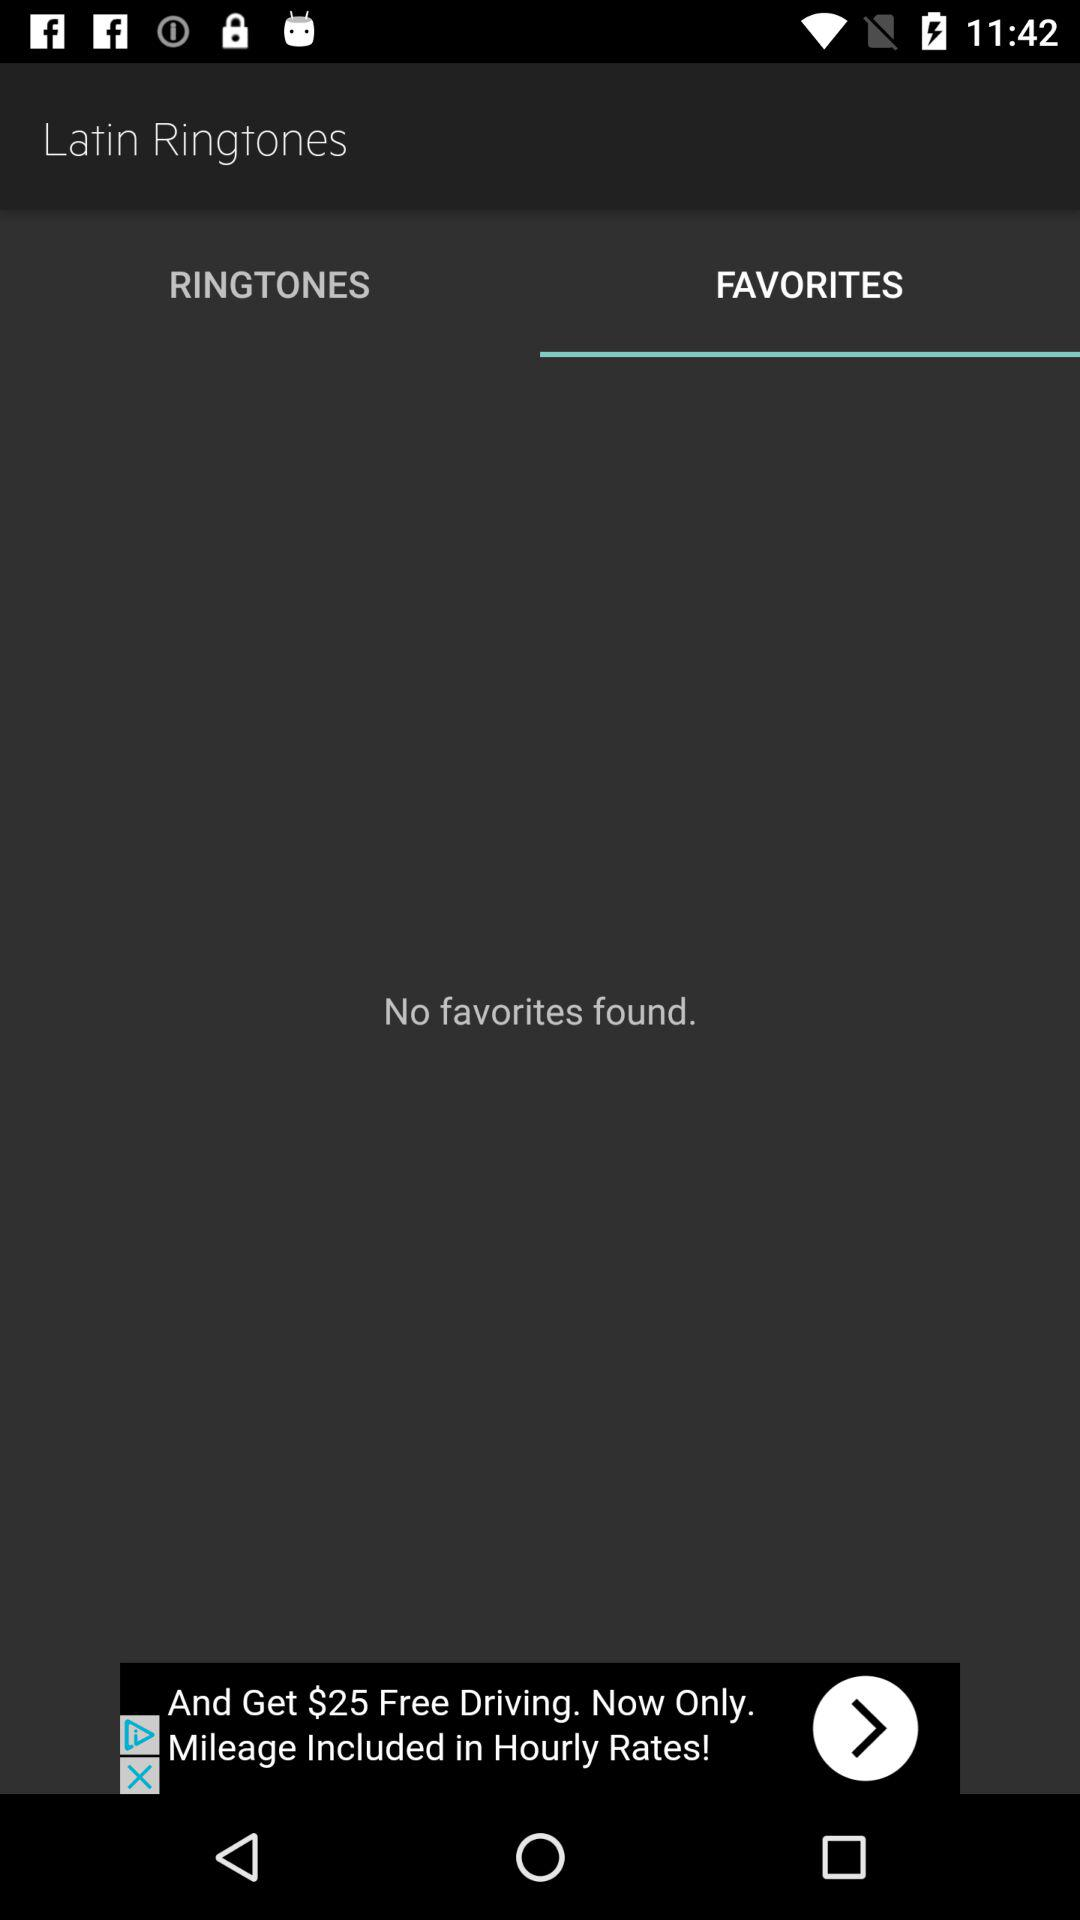Which option is selected for "Latin Ringtones"? The selected option is "FAVORITES". 